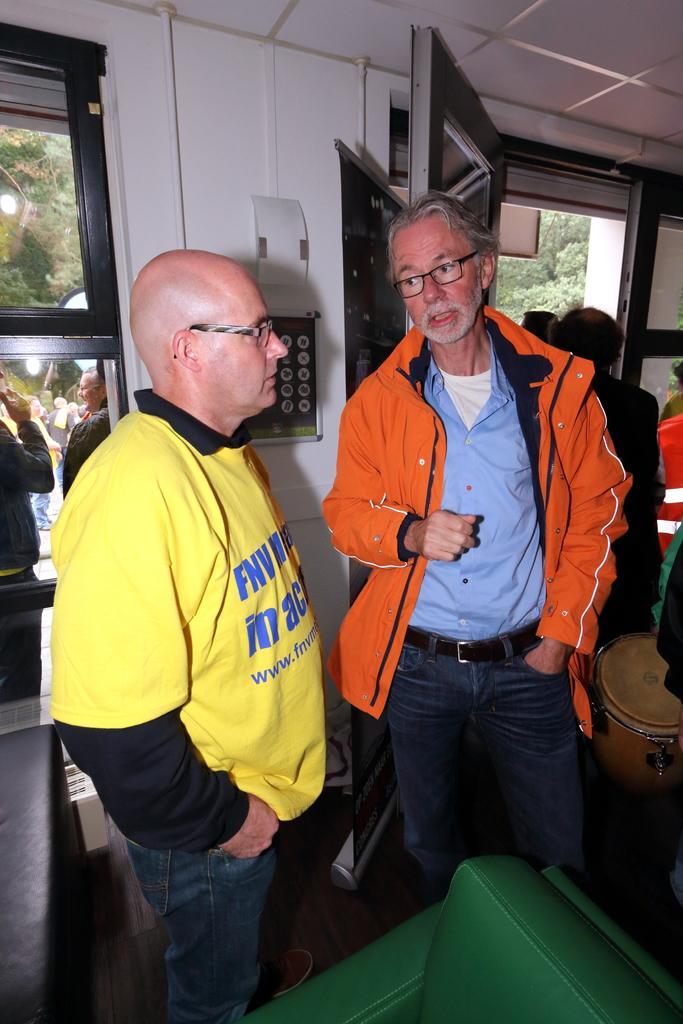Could you give a brief overview of what you see in this image? In the center of the image, we can see people standing and wearing glasses. In the background, we can see windows and through the window we can see some other people. At the top, there is roof and at the bottom, we can see a couch. 